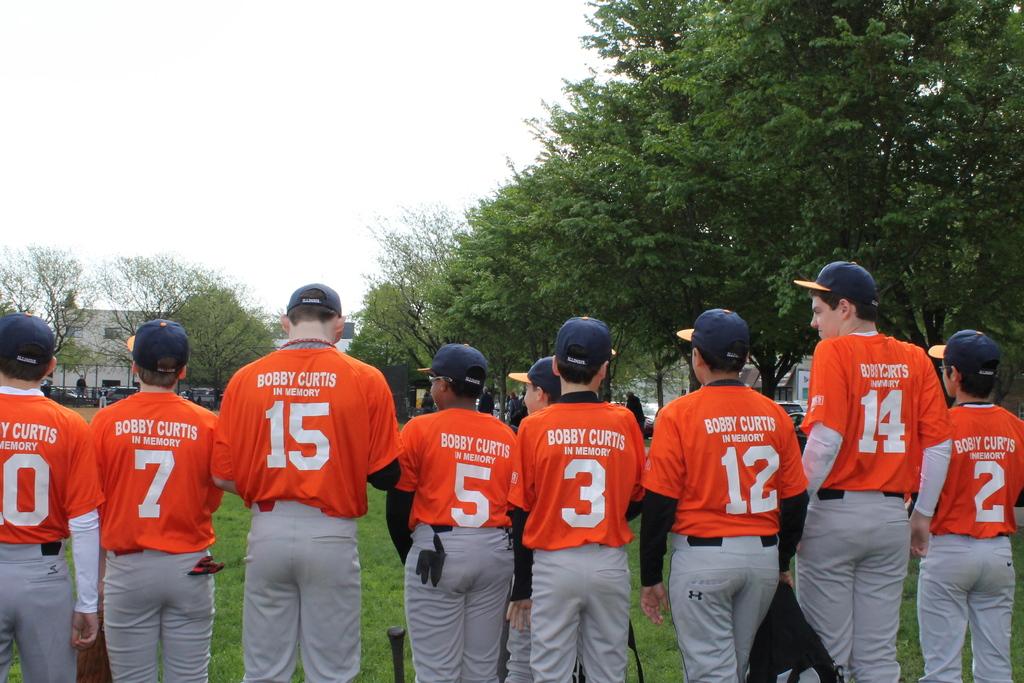What is the middle players number?
Offer a terse response. 5. 